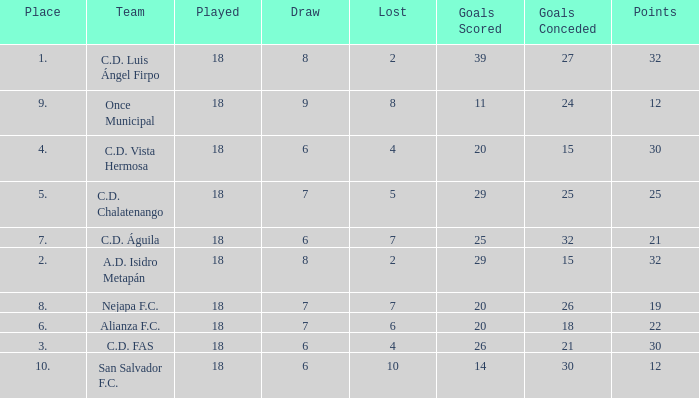Parse the full table. {'header': ['Place', 'Team', 'Played', 'Draw', 'Lost', 'Goals Scored', 'Goals Conceded', 'Points'], 'rows': [['1.', 'C.D. Luis Ángel Firpo', '18', '8', '2', '39', '27', '32'], ['9.', 'Once Municipal', '18', '9', '8', '11', '24', '12'], ['4.', 'C.D. Vista Hermosa', '18', '6', '4', '20', '15', '30'], ['5.', 'C.D. Chalatenango', '18', '7', '5', '29', '25', '25'], ['7.', 'C.D. Águila', '18', '6', '7', '25', '32', '21'], ['2.', 'A.D. Isidro Metapán', '18', '8', '2', '29', '15', '32'], ['8.', 'Nejapa F.C.', '18', '7', '7', '20', '26', '19'], ['6.', 'Alianza F.C.', '18', '7', '6', '20', '18', '22'], ['3.', 'C.D. FAS', '18', '6', '4', '26', '21', '30'], ['10.', 'San Salvador F.C.', '18', '6', '10', '14', '30', '12']]} What is the sum of draw with a lost smaller than 6, and a place of 5, and a goals scored less than 29? None. 